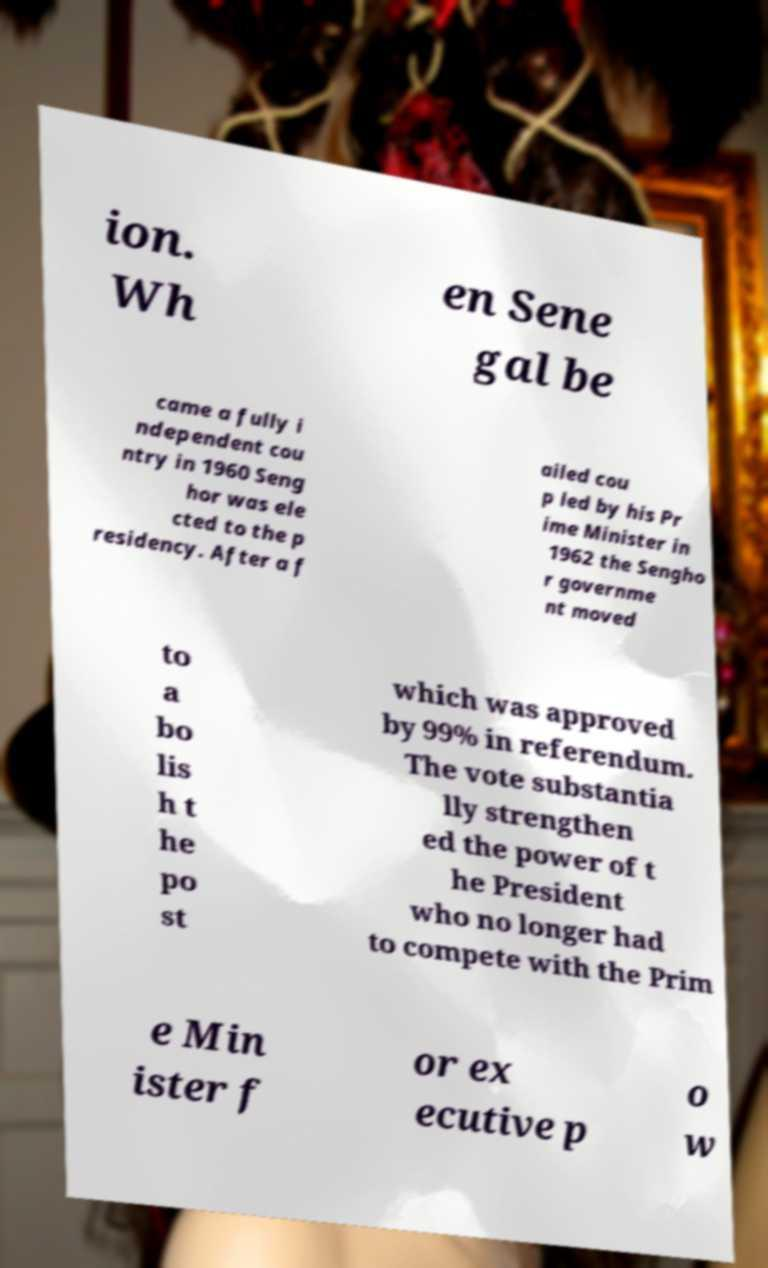For documentation purposes, I need the text within this image transcribed. Could you provide that? ion. Wh en Sene gal be came a fully i ndependent cou ntry in 1960 Seng hor was ele cted to the p residency. After a f ailed cou p led by his Pr ime Minister in 1962 the Sengho r governme nt moved to a bo lis h t he po st which was approved by 99% in referendum. The vote substantia lly strengthen ed the power of t he President who no longer had to compete with the Prim e Min ister f or ex ecutive p o w 